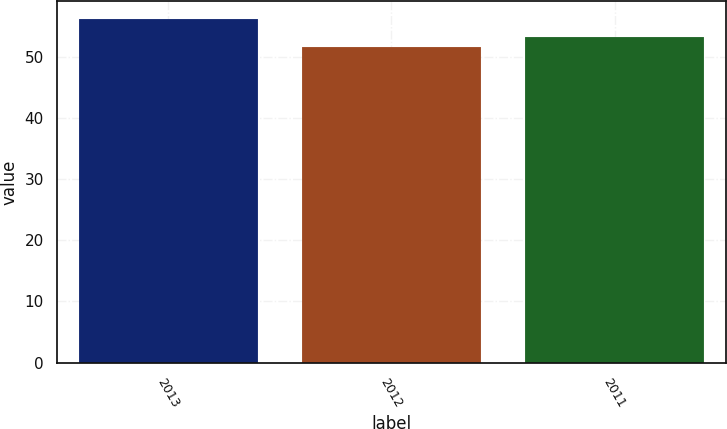Convert chart to OTSL. <chart><loc_0><loc_0><loc_500><loc_500><bar_chart><fcel>2013<fcel>2012<fcel>2011<nl><fcel>56.2<fcel>51.6<fcel>53.2<nl></chart> 